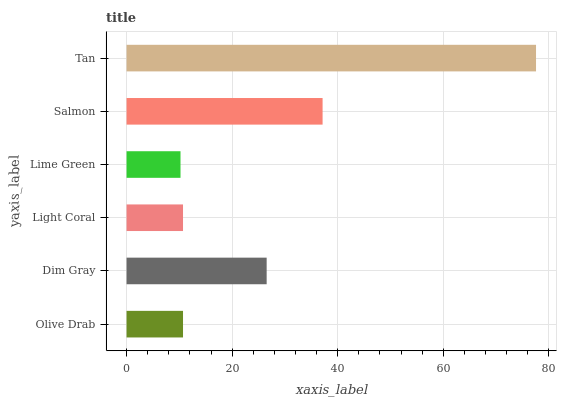Is Lime Green the minimum?
Answer yes or no. Yes. Is Tan the maximum?
Answer yes or no. Yes. Is Dim Gray the minimum?
Answer yes or no. No. Is Dim Gray the maximum?
Answer yes or no. No. Is Dim Gray greater than Olive Drab?
Answer yes or no. Yes. Is Olive Drab less than Dim Gray?
Answer yes or no. Yes. Is Olive Drab greater than Dim Gray?
Answer yes or no. No. Is Dim Gray less than Olive Drab?
Answer yes or no. No. Is Dim Gray the high median?
Answer yes or no. Yes. Is Olive Drab the low median?
Answer yes or no. Yes. Is Olive Drab the high median?
Answer yes or no. No. Is Salmon the low median?
Answer yes or no. No. 